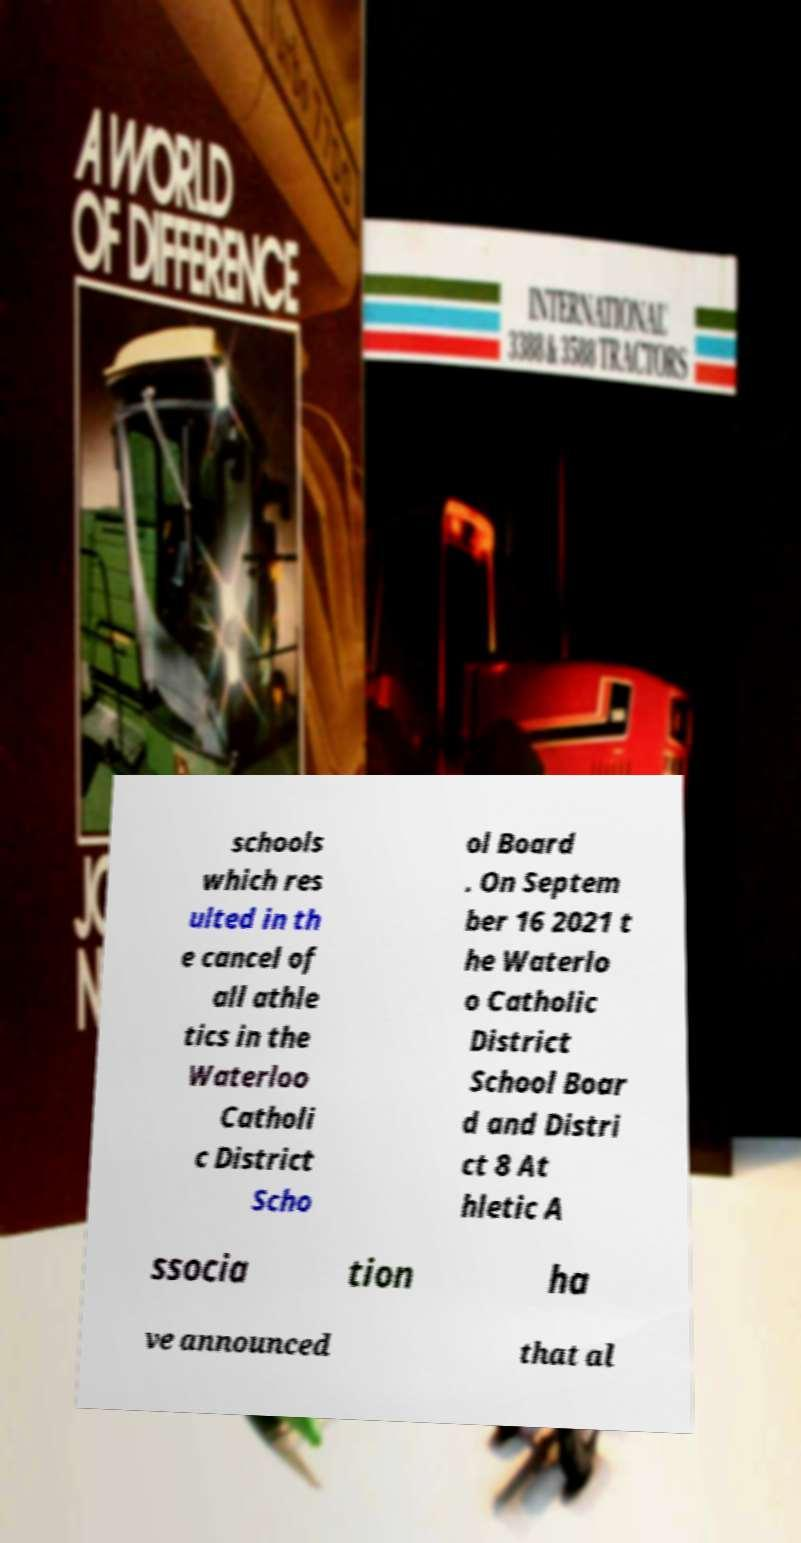Could you extract and type out the text from this image? schools which res ulted in th e cancel of all athle tics in the Waterloo Catholi c District Scho ol Board . On Septem ber 16 2021 t he Waterlo o Catholic District School Boar d and Distri ct 8 At hletic A ssocia tion ha ve announced that al 